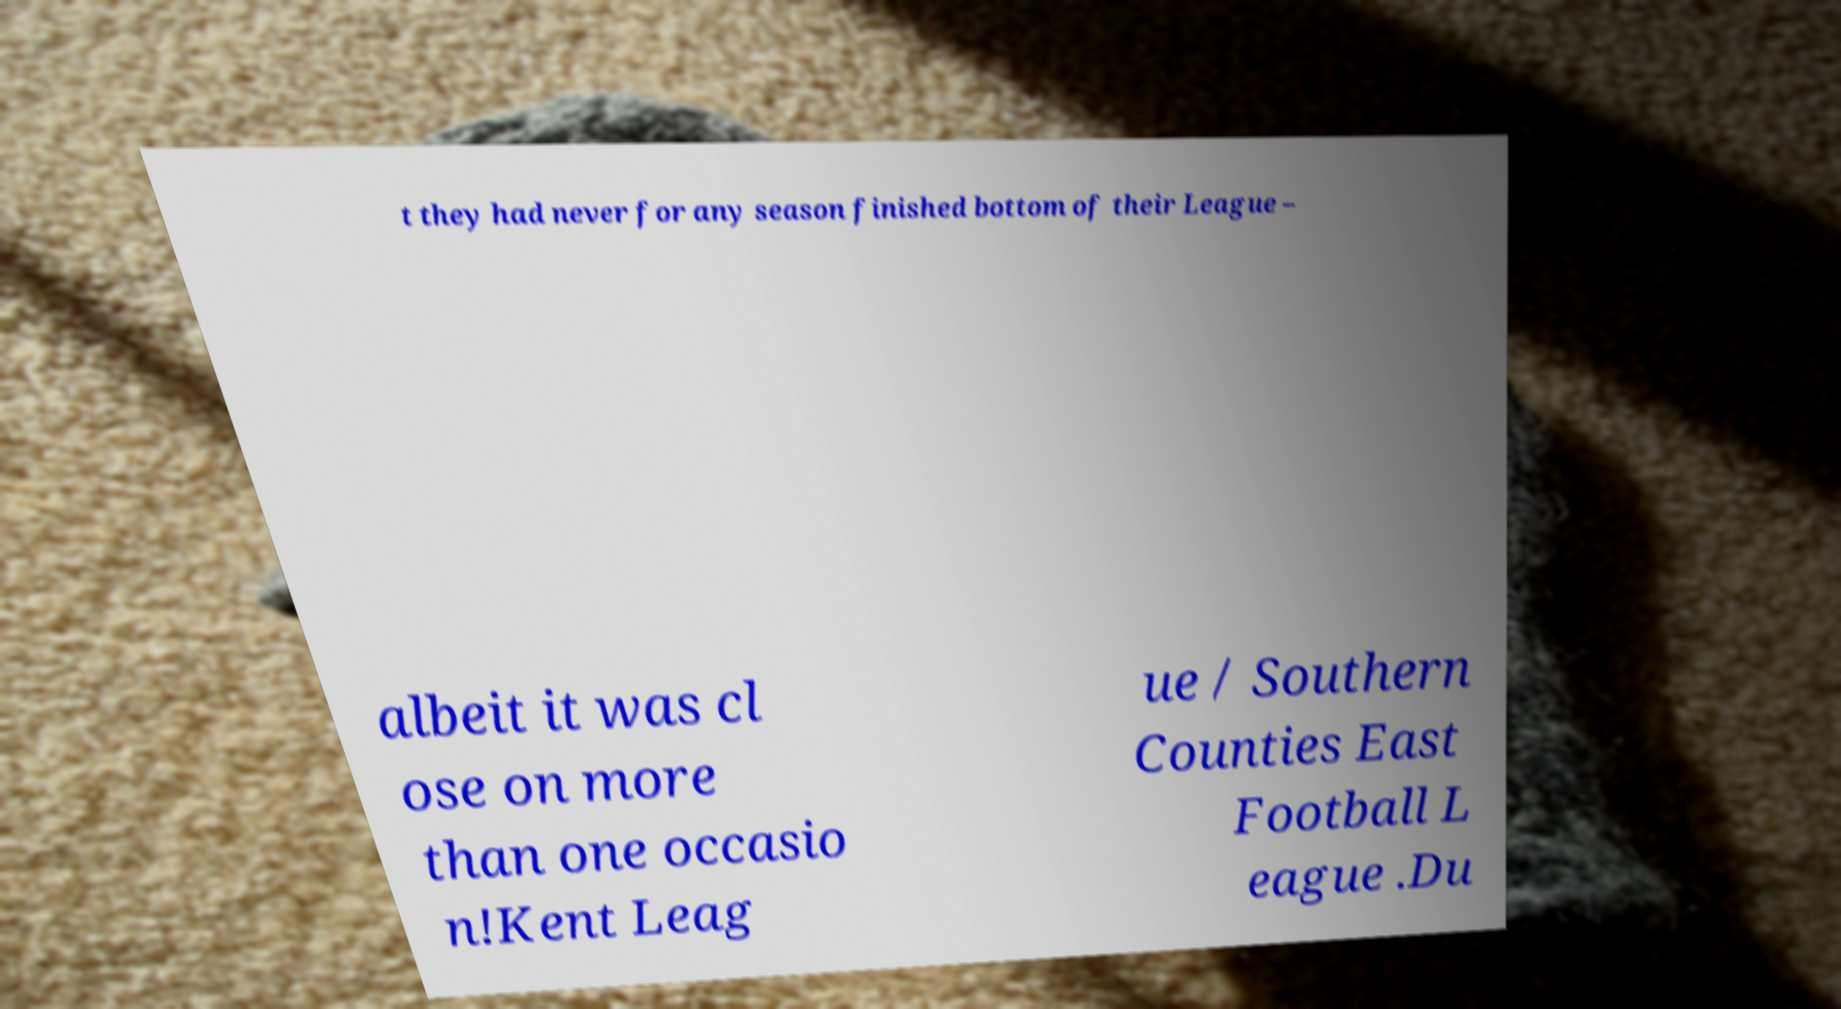Can you accurately transcribe the text from the provided image for me? t they had never for any season finished bottom of their League – albeit it was cl ose on more than one occasio n!Kent Leag ue / Southern Counties East Football L eague .Du 